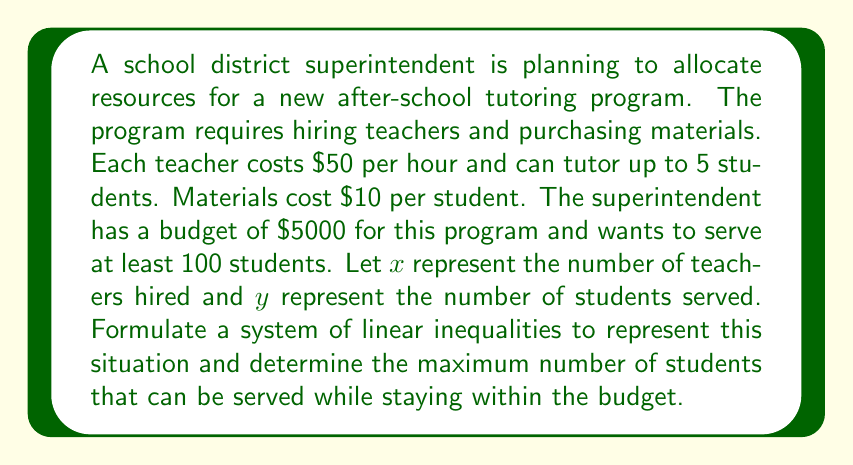Help me with this question. Let's approach this step-by-step:

1) First, let's identify the constraints:
   a) Budget constraint: The total cost must not exceed $5000
   b) Minimum students: At least 100 students must be served
   c) Teacher capacity: Each teacher can tutor up to 5 students

2) Now, let's formulate these constraints as inequalities:
   a) Budget constraint: 
      Cost of teachers + Cost of materials ≤ $5000
      $50x + $10y ≤ 5000$

   b) Minimum students:
      $y ≥ 100$

   c) Teacher capacity:
      $y ≤ 5x$

3) Our system of inequalities is:
   $$\begin{cases}
   50x + 10y \leq 5000 \\
   y \geq 100 \\
   y \leq 5x
   \end{cases}$$

4) To maximize the number of students served, we need to maximize $y$ subject to these constraints.

5) From the budget constraint, we can derive:
   $50x + 10y = 5000$
   $y = 500 - 5x$

6) This line intersects with $y = 5x$ at:
   $500 - 5x = 5x$
   $500 = 10x$
   $x = 50$

7) Substituting this back:
   $y = 500 - 5(50) = 250$

8) We need to check if this satisfies the minimum student constraint:
   250 > 100, so it does.

Therefore, the maximum number of students that can be served is 250.
Answer: The maximum number of students that can be served while staying within the budget is 250. 